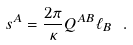Convert formula to latex. <formula><loc_0><loc_0><loc_500><loc_500>s ^ { A } = \frac { 2 \pi } { \kappa } Q ^ { A B } \ell _ { B } \ .</formula> 